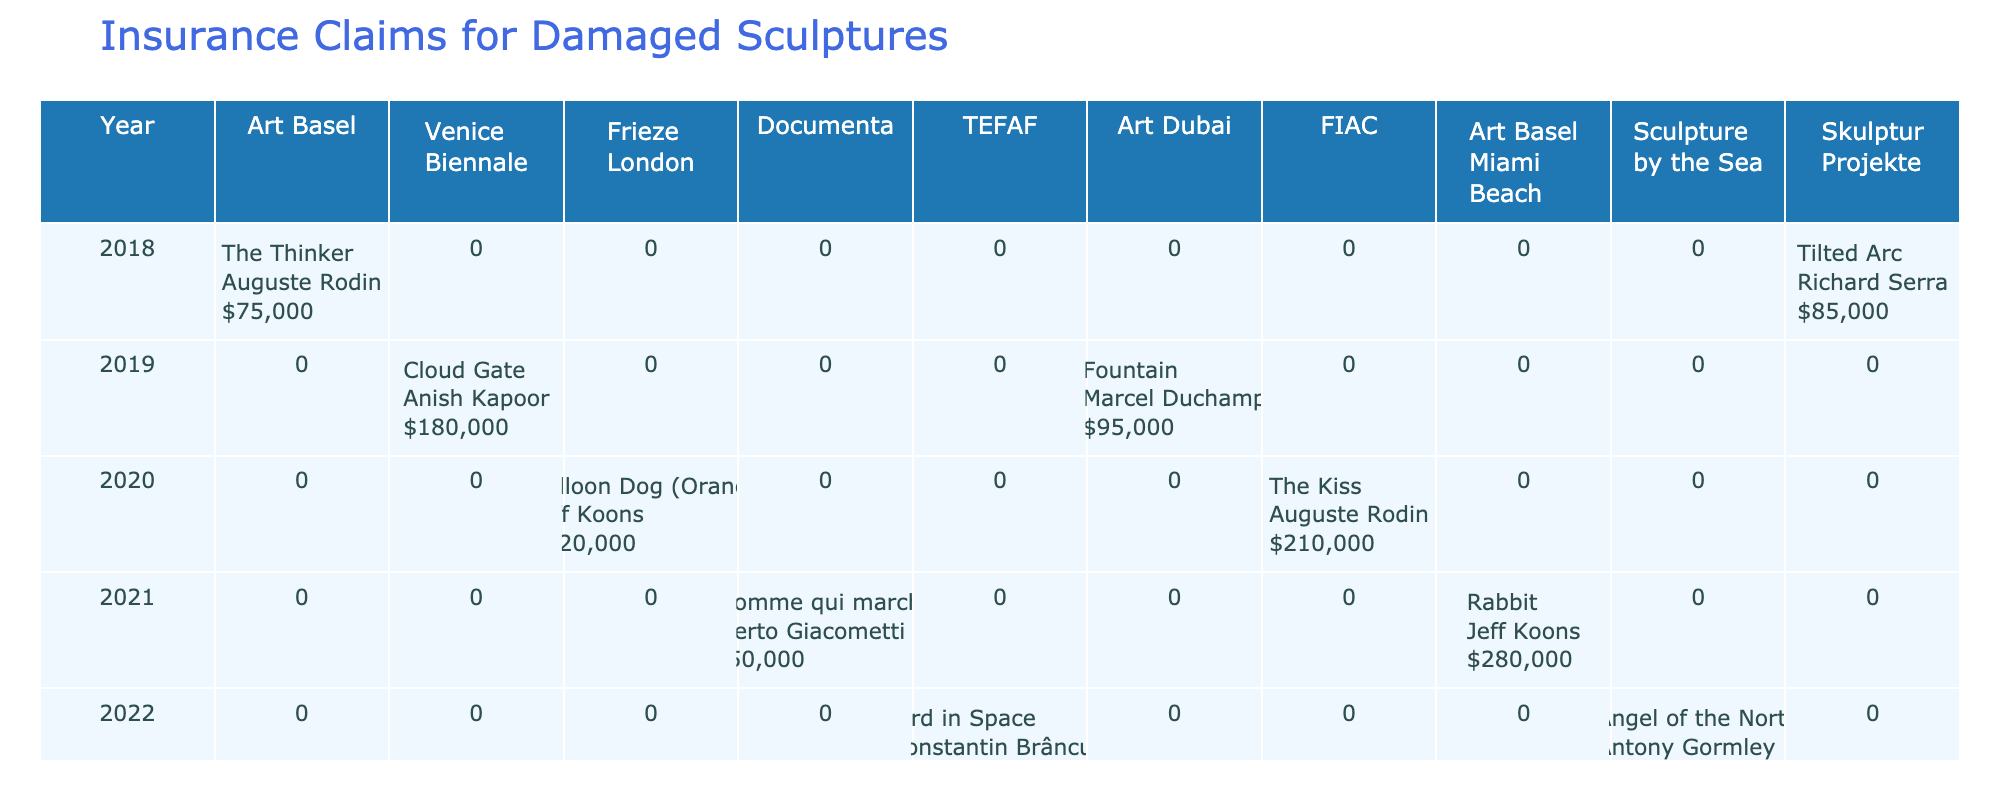What is the total claim amount for sculptures damaged in 2019? Reviewing the data, the claims filed in 2019 include: Cloud Gate ($180,000) and Fountain ($95,000). Summing these amounts gives $180,000 + $95,000 = $275,000.
Answer: $275,000 Which sculpture sustained damage due to humidity? Inspecting the table, the only sculpture listed with humidity damage is Rabbit, exhibited in Miami during 2021.
Answer: Rabbit In what year did the sculpture The Thinker incur a claim? By checking the table, The Thinker had a claim filed in 2018, during the Art Basel exhibition.
Answer: 2018 What was the average insured value of sculptures across all years? The insured values listed are: $15,000,000 (The Thinker), $23,000,000 (Cloud Gate), $58,400,000 (Balloon Dog), $104,300,000 (L'Homme qui marche I), $32,000,000 (Bird in Space), $2,800,000 (Fountain), $8,500,000 (The Kiss), $91,100,000 (Rabbit), and $6,700,000 (Angel of the North). Summing these gives $15,000,000 + $23,000,000 + $58,400,000 + $104,300,000 + $32,000,000 + $2,800,000 + $8,500,000 + $91,100,000 + $6,700,000 = $342,800,000. Dividing by 9 sculptures gives the average of approximately $38,089,222.
Answer: $38,089,222 Which artist had the highest single claim amount and what was that amount? Scanning through the claims, the highest single claim amount comes from L'Homme qui marche I by Alberto Giacometti, which claimed $950,000.
Answer: Alberto Giacometti, $950,000 Was there any claim due to vandalism? Checking the data for any mention of vandalism, it shows that the Fountain sculpture incurred a vandalism claim in 2019.
Answer: Yes How many different exhibitions had claims filed for sculptures in the year 2020? In 2020, there are two sculptures listed: Balloon Dog in London and The Kiss in Paris. Therefore, there are two different exhibitions with claims this year.
Answer: 2 What is the total number of sculptures listed in the table? Counting each sculpture entry in the table reveals there are nine distinct sculptures: The Thinker, Cloud Gate, Balloon Dog, L'Homme qui marche I, Bird in Space, Fountain, The Kiss, Rabbit, and Angel of the North.
Answer: 9 Which sculpture had surface dent damage and what was the claim amount? The table indicates that Balloon Dog (Orange) sustained surface dent damage and had a claim amount of $320,000.
Answer: Balloon Dog (Orange), $320,000 What is the difference in insured value between the most and least insured sculptures? The highest insured value is for L'Homme qui marche I ($104,300,000) and the lowest is Fountain ($2,800,000). The difference is $104,300,000 - $2,800,000 = $101,500,000.
Answer: $101,500,000 